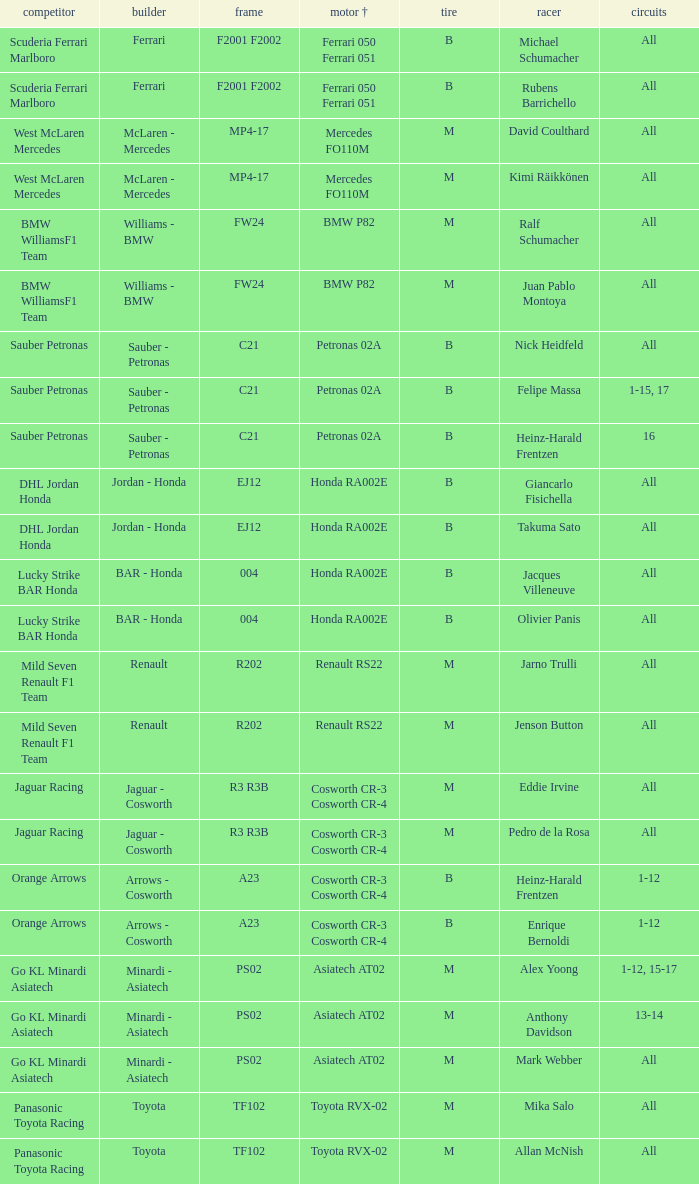What is the chassis when the tire is b, the motor is ferrari 050 ferrari 051, and the pilot is rubens barrichello? F2001 F2002. 